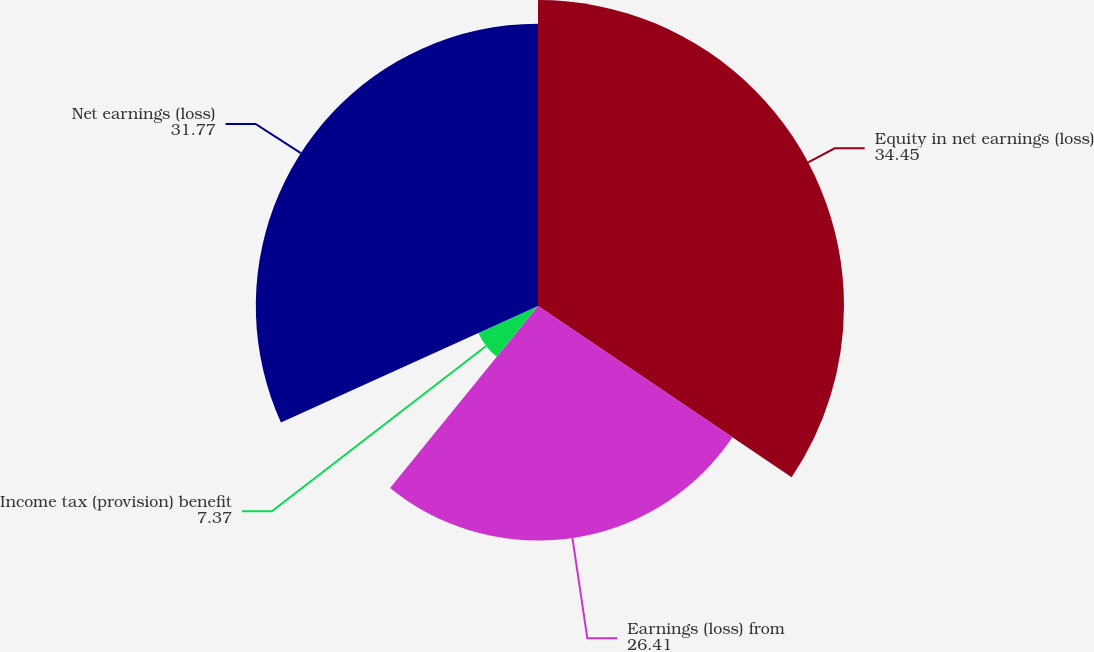Convert chart to OTSL. <chart><loc_0><loc_0><loc_500><loc_500><pie_chart><fcel>Equity in net earnings (loss)<fcel>Earnings (loss) from<fcel>Income tax (provision) benefit<fcel>Net earnings (loss)<nl><fcel>34.45%<fcel>26.41%<fcel>7.37%<fcel>31.77%<nl></chart> 